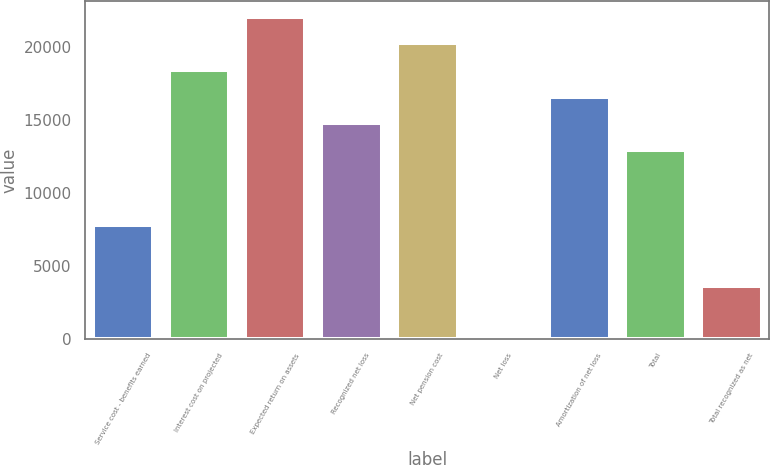Convert chart. <chart><loc_0><loc_0><loc_500><loc_500><bar_chart><fcel>Service cost - benefits earned<fcel>Interest cost on projected<fcel>Expected return on assets<fcel>Recognized net loss<fcel>Net pension cost<fcel>Net loss<fcel>Amortization of net loss<fcel>Total<fcel>Total recognized as net<nl><fcel>7827<fcel>18405<fcel>22039<fcel>14771<fcel>20222<fcel>101<fcel>16588<fcel>12954<fcel>3627<nl></chart> 